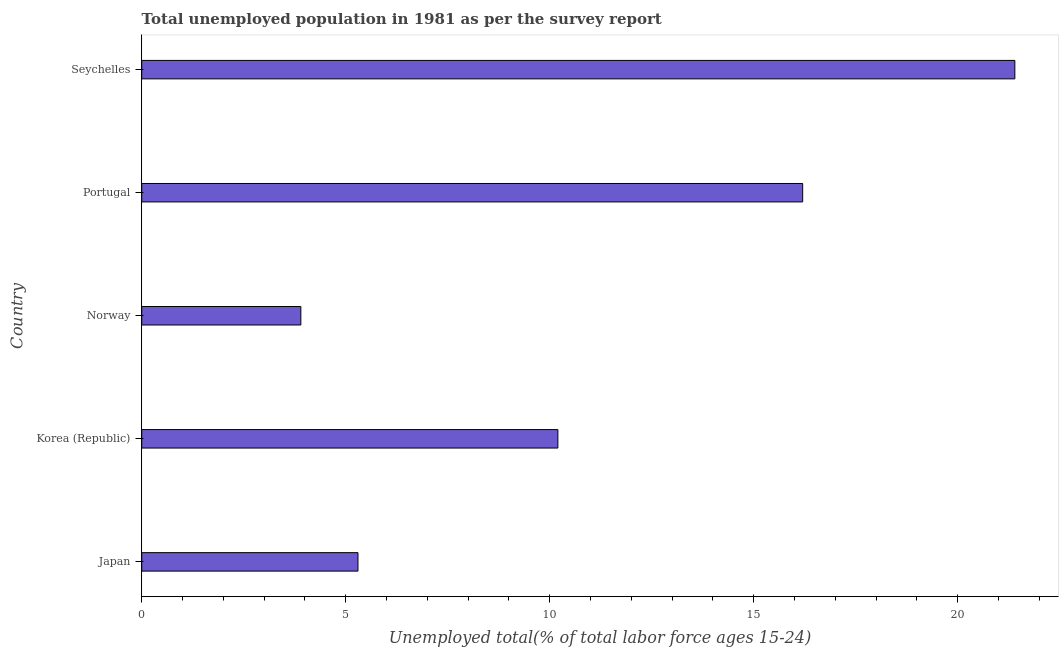Does the graph contain grids?
Give a very brief answer. No. What is the title of the graph?
Give a very brief answer. Total unemployed population in 1981 as per the survey report. What is the label or title of the X-axis?
Your response must be concise. Unemployed total(% of total labor force ages 15-24). What is the label or title of the Y-axis?
Give a very brief answer. Country. What is the unemployed youth in Portugal?
Your response must be concise. 16.2. Across all countries, what is the maximum unemployed youth?
Provide a short and direct response. 21.4. Across all countries, what is the minimum unemployed youth?
Ensure brevity in your answer.  3.9. In which country was the unemployed youth maximum?
Offer a very short reply. Seychelles. What is the sum of the unemployed youth?
Your answer should be compact. 57. What is the median unemployed youth?
Your answer should be very brief. 10.2. What is the ratio of the unemployed youth in Korea (Republic) to that in Norway?
Keep it short and to the point. 2.62. In how many countries, is the unemployed youth greater than the average unemployed youth taken over all countries?
Give a very brief answer. 2. Are all the bars in the graph horizontal?
Your answer should be compact. Yes. How many countries are there in the graph?
Keep it short and to the point. 5. What is the Unemployed total(% of total labor force ages 15-24) of Japan?
Offer a very short reply. 5.3. What is the Unemployed total(% of total labor force ages 15-24) in Korea (Republic)?
Provide a short and direct response. 10.2. What is the Unemployed total(% of total labor force ages 15-24) of Norway?
Your response must be concise. 3.9. What is the Unemployed total(% of total labor force ages 15-24) of Portugal?
Your answer should be compact. 16.2. What is the Unemployed total(% of total labor force ages 15-24) of Seychelles?
Offer a terse response. 21.4. What is the difference between the Unemployed total(% of total labor force ages 15-24) in Japan and Korea (Republic)?
Your answer should be compact. -4.9. What is the difference between the Unemployed total(% of total labor force ages 15-24) in Japan and Seychelles?
Your response must be concise. -16.1. What is the difference between the Unemployed total(% of total labor force ages 15-24) in Korea (Republic) and Norway?
Give a very brief answer. 6.3. What is the difference between the Unemployed total(% of total labor force ages 15-24) in Korea (Republic) and Seychelles?
Your answer should be very brief. -11.2. What is the difference between the Unemployed total(% of total labor force ages 15-24) in Norway and Portugal?
Offer a terse response. -12.3. What is the difference between the Unemployed total(% of total labor force ages 15-24) in Norway and Seychelles?
Your answer should be very brief. -17.5. What is the ratio of the Unemployed total(% of total labor force ages 15-24) in Japan to that in Korea (Republic)?
Offer a very short reply. 0.52. What is the ratio of the Unemployed total(% of total labor force ages 15-24) in Japan to that in Norway?
Your answer should be very brief. 1.36. What is the ratio of the Unemployed total(% of total labor force ages 15-24) in Japan to that in Portugal?
Make the answer very short. 0.33. What is the ratio of the Unemployed total(% of total labor force ages 15-24) in Japan to that in Seychelles?
Make the answer very short. 0.25. What is the ratio of the Unemployed total(% of total labor force ages 15-24) in Korea (Republic) to that in Norway?
Ensure brevity in your answer.  2.62. What is the ratio of the Unemployed total(% of total labor force ages 15-24) in Korea (Republic) to that in Portugal?
Your response must be concise. 0.63. What is the ratio of the Unemployed total(% of total labor force ages 15-24) in Korea (Republic) to that in Seychelles?
Your answer should be very brief. 0.48. What is the ratio of the Unemployed total(% of total labor force ages 15-24) in Norway to that in Portugal?
Your response must be concise. 0.24. What is the ratio of the Unemployed total(% of total labor force ages 15-24) in Norway to that in Seychelles?
Your response must be concise. 0.18. What is the ratio of the Unemployed total(% of total labor force ages 15-24) in Portugal to that in Seychelles?
Give a very brief answer. 0.76. 